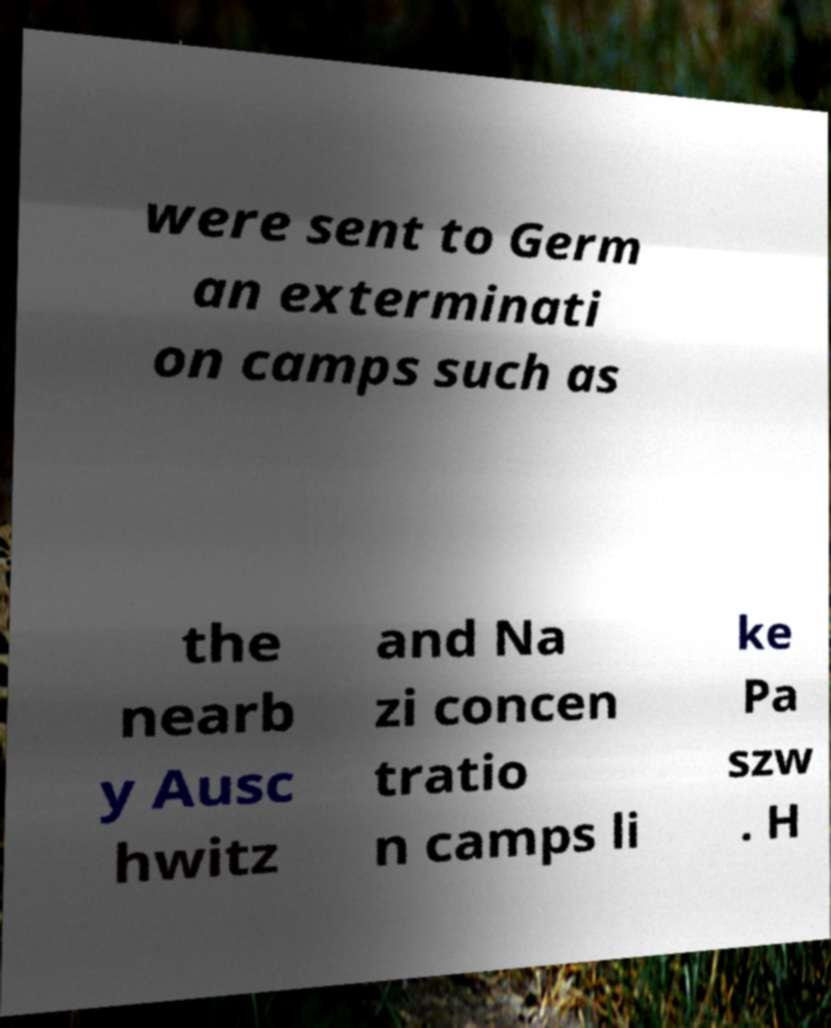Please identify and transcribe the text found in this image. were sent to Germ an exterminati on camps such as the nearb y Ausc hwitz and Na zi concen tratio n camps li ke Pa szw . H 